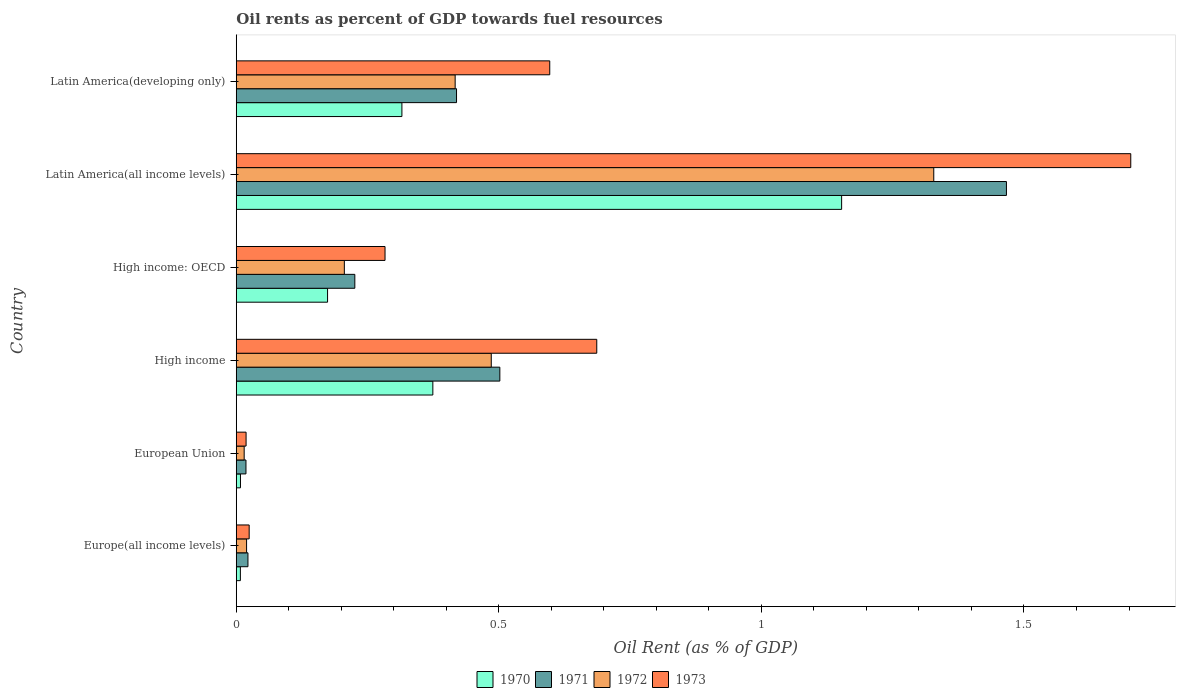How many different coloured bars are there?
Your answer should be compact. 4. Are the number of bars on each tick of the Y-axis equal?
Offer a very short reply. Yes. How many bars are there on the 6th tick from the top?
Offer a terse response. 4. What is the label of the 6th group of bars from the top?
Give a very brief answer. Europe(all income levels). In how many cases, is the number of bars for a given country not equal to the number of legend labels?
Offer a very short reply. 0. What is the oil rent in 1970 in High income: OECD?
Ensure brevity in your answer.  0.17. Across all countries, what is the maximum oil rent in 1972?
Make the answer very short. 1.33. Across all countries, what is the minimum oil rent in 1970?
Provide a succinct answer. 0.01. In which country was the oil rent in 1971 maximum?
Provide a succinct answer. Latin America(all income levels). In which country was the oil rent in 1970 minimum?
Keep it short and to the point. Europe(all income levels). What is the total oil rent in 1972 in the graph?
Your answer should be compact. 2.47. What is the difference between the oil rent in 1971 in Europe(all income levels) and that in High income?
Keep it short and to the point. -0.48. What is the difference between the oil rent in 1973 in Latin America(all income levels) and the oil rent in 1971 in European Union?
Your answer should be very brief. 1.68. What is the average oil rent in 1973 per country?
Your response must be concise. 0.55. What is the difference between the oil rent in 1970 and oil rent in 1971 in High income?
Provide a succinct answer. -0.13. What is the ratio of the oil rent in 1971 in Europe(all income levels) to that in High income?
Make the answer very short. 0.04. Is the oil rent in 1973 in High income: OECD less than that in Latin America(developing only)?
Your response must be concise. Yes. Is the difference between the oil rent in 1970 in Europe(all income levels) and High income greater than the difference between the oil rent in 1971 in Europe(all income levels) and High income?
Provide a succinct answer. Yes. What is the difference between the highest and the second highest oil rent in 1972?
Make the answer very short. 0.84. What is the difference between the highest and the lowest oil rent in 1971?
Ensure brevity in your answer.  1.45. In how many countries, is the oil rent in 1971 greater than the average oil rent in 1971 taken over all countries?
Your answer should be compact. 2. Are all the bars in the graph horizontal?
Your answer should be compact. Yes. Does the graph contain any zero values?
Offer a very short reply. No. Does the graph contain grids?
Provide a succinct answer. No. Where does the legend appear in the graph?
Ensure brevity in your answer.  Bottom center. How are the legend labels stacked?
Offer a terse response. Horizontal. What is the title of the graph?
Keep it short and to the point. Oil rents as percent of GDP towards fuel resources. What is the label or title of the X-axis?
Give a very brief answer. Oil Rent (as % of GDP). What is the Oil Rent (as % of GDP) of 1970 in Europe(all income levels)?
Provide a succinct answer. 0.01. What is the Oil Rent (as % of GDP) in 1971 in Europe(all income levels)?
Provide a short and direct response. 0.02. What is the Oil Rent (as % of GDP) in 1972 in Europe(all income levels)?
Ensure brevity in your answer.  0.02. What is the Oil Rent (as % of GDP) of 1973 in Europe(all income levels)?
Offer a very short reply. 0.02. What is the Oil Rent (as % of GDP) of 1970 in European Union?
Offer a terse response. 0.01. What is the Oil Rent (as % of GDP) of 1971 in European Union?
Your answer should be very brief. 0.02. What is the Oil Rent (as % of GDP) of 1972 in European Union?
Provide a short and direct response. 0.02. What is the Oil Rent (as % of GDP) of 1973 in European Union?
Offer a terse response. 0.02. What is the Oil Rent (as % of GDP) in 1970 in High income?
Ensure brevity in your answer.  0.37. What is the Oil Rent (as % of GDP) in 1971 in High income?
Your response must be concise. 0.5. What is the Oil Rent (as % of GDP) in 1972 in High income?
Offer a very short reply. 0.49. What is the Oil Rent (as % of GDP) of 1973 in High income?
Give a very brief answer. 0.69. What is the Oil Rent (as % of GDP) of 1970 in High income: OECD?
Ensure brevity in your answer.  0.17. What is the Oil Rent (as % of GDP) of 1971 in High income: OECD?
Give a very brief answer. 0.23. What is the Oil Rent (as % of GDP) in 1972 in High income: OECD?
Your answer should be very brief. 0.21. What is the Oil Rent (as % of GDP) of 1973 in High income: OECD?
Offer a terse response. 0.28. What is the Oil Rent (as % of GDP) of 1970 in Latin America(all income levels)?
Your answer should be compact. 1.15. What is the Oil Rent (as % of GDP) of 1971 in Latin America(all income levels)?
Offer a very short reply. 1.47. What is the Oil Rent (as % of GDP) in 1972 in Latin America(all income levels)?
Keep it short and to the point. 1.33. What is the Oil Rent (as % of GDP) of 1973 in Latin America(all income levels)?
Your response must be concise. 1.7. What is the Oil Rent (as % of GDP) of 1970 in Latin America(developing only)?
Ensure brevity in your answer.  0.32. What is the Oil Rent (as % of GDP) in 1971 in Latin America(developing only)?
Provide a short and direct response. 0.42. What is the Oil Rent (as % of GDP) in 1972 in Latin America(developing only)?
Ensure brevity in your answer.  0.42. What is the Oil Rent (as % of GDP) in 1973 in Latin America(developing only)?
Provide a short and direct response. 0.6. Across all countries, what is the maximum Oil Rent (as % of GDP) of 1970?
Make the answer very short. 1.15. Across all countries, what is the maximum Oil Rent (as % of GDP) of 1971?
Keep it short and to the point. 1.47. Across all countries, what is the maximum Oil Rent (as % of GDP) in 1972?
Provide a succinct answer. 1.33. Across all countries, what is the maximum Oil Rent (as % of GDP) in 1973?
Offer a very short reply. 1.7. Across all countries, what is the minimum Oil Rent (as % of GDP) of 1970?
Provide a short and direct response. 0.01. Across all countries, what is the minimum Oil Rent (as % of GDP) of 1971?
Provide a succinct answer. 0.02. Across all countries, what is the minimum Oil Rent (as % of GDP) of 1972?
Ensure brevity in your answer.  0.02. Across all countries, what is the minimum Oil Rent (as % of GDP) in 1973?
Ensure brevity in your answer.  0.02. What is the total Oil Rent (as % of GDP) of 1970 in the graph?
Provide a succinct answer. 2.03. What is the total Oil Rent (as % of GDP) in 1971 in the graph?
Ensure brevity in your answer.  2.65. What is the total Oil Rent (as % of GDP) in 1972 in the graph?
Your answer should be compact. 2.47. What is the total Oil Rent (as % of GDP) of 1973 in the graph?
Offer a very short reply. 3.31. What is the difference between the Oil Rent (as % of GDP) of 1970 in Europe(all income levels) and that in European Union?
Keep it short and to the point. -0. What is the difference between the Oil Rent (as % of GDP) in 1971 in Europe(all income levels) and that in European Union?
Make the answer very short. 0. What is the difference between the Oil Rent (as % of GDP) in 1972 in Europe(all income levels) and that in European Union?
Offer a terse response. 0. What is the difference between the Oil Rent (as % of GDP) in 1973 in Europe(all income levels) and that in European Union?
Give a very brief answer. 0.01. What is the difference between the Oil Rent (as % of GDP) in 1970 in Europe(all income levels) and that in High income?
Your answer should be compact. -0.37. What is the difference between the Oil Rent (as % of GDP) in 1971 in Europe(all income levels) and that in High income?
Give a very brief answer. -0.48. What is the difference between the Oil Rent (as % of GDP) in 1972 in Europe(all income levels) and that in High income?
Provide a short and direct response. -0.47. What is the difference between the Oil Rent (as % of GDP) of 1973 in Europe(all income levels) and that in High income?
Your answer should be compact. -0.66. What is the difference between the Oil Rent (as % of GDP) of 1970 in Europe(all income levels) and that in High income: OECD?
Offer a terse response. -0.17. What is the difference between the Oil Rent (as % of GDP) of 1971 in Europe(all income levels) and that in High income: OECD?
Give a very brief answer. -0.2. What is the difference between the Oil Rent (as % of GDP) in 1972 in Europe(all income levels) and that in High income: OECD?
Ensure brevity in your answer.  -0.19. What is the difference between the Oil Rent (as % of GDP) in 1973 in Europe(all income levels) and that in High income: OECD?
Provide a succinct answer. -0.26. What is the difference between the Oil Rent (as % of GDP) in 1970 in Europe(all income levels) and that in Latin America(all income levels)?
Make the answer very short. -1.14. What is the difference between the Oil Rent (as % of GDP) of 1971 in Europe(all income levels) and that in Latin America(all income levels)?
Your response must be concise. -1.44. What is the difference between the Oil Rent (as % of GDP) of 1972 in Europe(all income levels) and that in Latin America(all income levels)?
Give a very brief answer. -1.31. What is the difference between the Oil Rent (as % of GDP) of 1973 in Europe(all income levels) and that in Latin America(all income levels)?
Your answer should be very brief. -1.68. What is the difference between the Oil Rent (as % of GDP) of 1970 in Europe(all income levels) and that in Latin America(developing only)?
Your answer should be very brief. -0.31. What is the difference between the Oil Rent (as % of GDP) in 1971 in Europe(all income levels) and that in Latin America(developing only)?
Your answer should be compact. -0.4. What is the difference between the Oil Rent (as % of GDP) in 1972 in Europe(all income levels) and that in Latin America(developing only)?
Provide a succinct answer. -0.4. What is the difference between the Oil Rent (as % of GDP) of 1973 in Europe(all income levels) and that in Latin America(developing only)?
Offer a very short reply. -0.57. What is the difference between the Oil Rent (as % of GDP) in 1970 in European Union and that in High income?
Provide a succinct answer. -0.37. What is the difference between the Oil Rent (as % of GDP) in 1971 in European Union and that in High income?
Your answer should be compact. -0.48. What is the difference between the Oil Rent (as % of GDP) in 1972 in European Union and that in High income?
Offer a terse response. -0.47. What is the difference between the Oil Rent (as % of GDP) of 1973 in European Union and that in High income?
Provide a succinct answer. -0.67. What is the difference between the Oil Rent (as % of GDP) of 1970 in European Union and that in High income: OECD?
Your response must be concise. -0.17. What is the difference between the Oil Rent (as % of GDP) in 1971 in European Union and that in High income: OECD?
Keep it short and to the point. -0.21. What is the difference between the Oil Rent (as % of GDP) in 1972 in European Union and that in High income: OECD?
Offer a very short reply. -0.19. What is the difference between the Oil Rent (as % of GDP) in 1973 in European Union and that in High income: OECD?
Your answer should be compact. -0.26. What is the difference between the Oil Rent (as % of GDP) of 1970 in European Union and that in Latin America(all income levels)?
Your response must be concise. -1.14. What is the difference between the Oil Rent (as % of GDP) in 1971 in European Union and that in Latin America(all income levels)?
Give a very brief answer. -1.45. What is the difference between the Oil Rent (as % of GDP) in 1972 in European Union and that in Latin America(all income levels)?
Ensure brevity in your answer.  -1.31. What is the difference between the Oil Rent (as % of GDP) of 1973 in European Union and that in Latin America(all income levels)?
Make the answer very short. -1.68. What is the difference between the Oil Rent (as % of GDP) in 1970 in European Union and that in Latin America(developing only)?
Offer a very short reply. -0.31. What is the difference between the Oil Rent (as % of GDP) of 1971 in European Union and that in Latin America(developing only)?
Ensure brevity in your answer.  -0.4. What is the difference between the Oil Rent (as % of GDP) in 1972 in European Union and that in Latin America(developing only)?
Provide a short and direct response. -0.4. What is the difference between the Oil Rent (as % of GDP) of 1973 in European Union and that in Latin America(developing only)?
Provide a short and direct response. -0.58. What is the difference between the Oil Rent (as % of GDP) in 1970 in High income and that in High income: OECD?
Ensure brevity in your answer.  0.2. What is the difference between the Oil Rent (as % of GDP) in 1971 in High income and that in High income: OECD?
Your answer should be compact. 0.28. What is the difference between the Oil Rent (as % of GDP) of 1972 in High income and that in High income: OECD?
Offer a terse response. 0.28. What is the difference between the Oil Rent (as % of GDP) of 1973 in High income and that in High income: OECD?
Ensure brevity in your answer.  0.4. What is the difference between the Oil Rent (as % of GDP) in 1970 in High income and that in Latin America(all income levels)?
Your answer should be compact. -0.78. What is the difference between the Oil Rent (as % of GDP) of 1971 in High income and that in Latin America(all income levels)?
Your answer should be compact. -0.96. What is the difference between the Oil Rent (as % of GDP) in 1972 in High income and that in Latin America(all income levels)?
Your answer should be very brief. -0.84. What is the difference between the Oil Rent (as % of GDP) in 1973 in High income and that in Latin America(all income levels)?
Your answer should be compact. -1.02. What is the difference between the Oil Rent (as % of GDP) of 1970 in High income and that in Latin America(developing only)?
Keep it short and to the point. 0.06. What is the difference between the Oil Rent (as % of GDP) in 1971 in High income and that in Latin America(developing only)?
Your answer should be compact. 0.08. What is the difference between the Oil Rent (as % of GDP) in 1972 in High income and that in Latin America(developing only)?
Your response must be concise. 0.07. What is the difference between the Oil Rent (as % of GDP) of 1973 in High income and that in Latin America(developing only)?
Give a very brief answer. 0.09. What is the difference between the Oil Rent (as % of GDP) of 1970 in High income: OECD and that in Latin America(all income levels)?
Offer a very short reply. -0.98. What is the difference between the Oil Rent (as % of GDP) in 1971 in High income: OECD and that in Latin America(all income levels)?
Ensure brevity in your answer.  -1.24. What is the difference between the Oil Rent (as % of GDP) of 1972 in High income: OECD and that in Latin America(all income levels)?
Offer a terse response. -1.12. What is the difference between the Oil Rent (as % of GDP) in 1973 in High income: OECD and that in Latin America(all income levels)?
Keep it short and to the point. -1.42. What is the difference between the Oil Rent (as % of GDP) of 1970 in High income: OECD and that in Latin America(developing only)?
Ensure brevity in your answer.  -0.14. What is the difference between the Oil Rent (as % of GDP) in 1971 in High income: OECD and that in Latin America(developing only)?
Provide a succinct answer. -0.19. What is the difference between the Oil Rent (as % of GDP) of 1972 in High income: OECD and that in Latin America(developing only)?
Offer a terse response. -0.21. What is the difference between the Oil Rent (as % of GDP) in 1973 in High income: OECD and that in Latin America(developing only)?
Your answer should be compact. -0.31. What is the difference between the Oil Rent (as % of GDP) in 1970 in Latin America(all income levels) and that in Latin America(developing only)?
Your response must be concise. 0.84. What is the difference between the Oil Rent (as % of GDP) in 1971 in Latin America(all income levels) and that in Latin America(developing only)?
Give a very brief answer. 1.05. What is the difference between the Oil Rent (as % of GDP) of 1972 in Latin America(all income levels) and that in Latin America(developing only)?
Your answer should be compact. 0.91. What is the difference between the Oil Rent (as % of GDP) of 1973 in Latin America(all income levels) and that in Latin America(developing only)?
Your response must be concise. 1.11. What is the difference between the Oil Rent (as % of GDP) in 1970 in Europe(all income levels) and the Oil Rent (as % of GDP) in 1971 in European Union?
Offer a terse response. -0.01. What is the difference between the Oil Rent (as % of GDP) of 1970 in Europe(all income levels) and the Oil Rent (as % of GDP) of 1972 in European Union?
Your answer should be compact. -0.01. What is the difference between the Oil Rent (as % of GDP) in 1970 in Europe(all income levels) and the Oil Rent (as % of GDP) in 1973 in European Union?
Provide a succinct answer. -0.01. What is the difference between the Oil Rent (as % of GDP) of 1971 in Europe(all income levels) and the Oil Rent (as % of GDP) of 1972 in European Union?
Your answer should be compact. 0.01. What is the difference between the Oil Rent (as % of GDP) of 1971 in Europe(all income levels) and the Oil Rent (as % of GDP) of 1973 in European Union?
Ensure brevity in your answer.  0. What is the difference between the Oil Rent (as % of GDP) in 1972 in Europe(all income levels) and the Oil Rent (as % of GDP) in 1973 in European Union?
Offer a very short reply. 0. What is the difference between the Oil Rent (as % of GDP) of 1970 in Europe(all income levels) and the Oil Rent (as % of GDP) of 1971 in High income?
Your answer should be very brief. -0.49. What is the difference between the Oil Rent (as % of GDP) in 1970 in Europe(all income levels) and the Oil Rent (as % of GDP) in 1972 in High income?
Give a very brief answer. -0.48. What is the difference between the Oil Rent (as % of GDP) of 1970 in Europe(all income levels) and the Oil Rent (as % of GDP) of 1973 in High income?
Offer a very short reply. -0.68. What is the difference between the Oil Rent (as % of GDP) of 1971 in Europe(all income levels) and the Oil Rent (as % of GDP) of 1972 in High income?
Offer a very short reply. -0.46. What is the difference between the Oil Rent (as % of GDP) of 1971 in Europe(all income levels) and the Oil Rent (as % of GDP) of 1973 in High income?
Offer a very short reply. -0.66. What is the difference between the Oil Rent (as % of GDP) in 1972 in Europe(all income levels) and the Oil Rent (as % of GDP) in 1973 in High income?
Offer a terse response. -0.67. What is the difference between the Oil Rent (as % of GDP) of 1970 in Europe(all income levels) and the Oil Rent (as % of GDP) of 1971 in High income: OECD?
Your response must be concise. -0.22. What is the difference between the Oil Rent (as % of GDP) of 1970 in Europe(all income levels) and the Oil Rent (as % of GDP) of 1972 in High income: OECD?
Offer a terse response. -0.2. What is the difference between the Oil Rent (as % of GDP) of 1970 in Europe(all income levels) and the Oil Rent (as % of GDP) of 1973 in High income: OECD?
Your answer should be compact. -0.28. What is the difference between the Oil Rent (as % of GDP) of 1971 in Europe(all income levels) and the Oil Rent (as % of GDP) of 1972 in High income: OECD?
Provide a short and direct response. -0.18. What is the difference between the Oil Rent (as % of GDP) of 1971 in Europe(all income levels) and the Oil Rent (as % of GDP) of 1973 in High income: OECD?
Offer a very short reply. -0.26. What is the difference between the Oil Rent (as % of GDP) in 1972 in Europe(all income levels) and the Oil Rent (as % of GDP) in 1973 in High income: OECD?
Your answer should be very brief. -0.26. What is the difference between the Oil Rent (as % of GDP) of 1970 in Europe(all income levels) and the Oil Rent (as % of GDP) of 1971 in Latin America(all income levels)?
Offer a very short reply. -1.46. What is the difference between the Oil Rent (as % of GDP) of 1970 in Europe(all income levels) and the Oil Rent (as % of GDP) of 1972 in Latin America(all income levels)?
Provide a succinct answer. -1.32. What is the difference between the Oil Rent (as % of GDP) in 1970 in Europe(all income levels) and the Oil Rent (as % of GDP) in 1973 in Latin America(all income levels)?
Make the answer very short. -1.7. What is the difference between the Oil Rent (as % of GDP) in 1971 in Europe(all income levels) and the Oil Rent (as % of GDP) in 1972 in Latin America(all income levels)?
Provide a succinct answer. -1.31. What is the difference between the Oil Rent (as % of GDP) of 1971 in Europe(all income levels) and the Oil Rent (as % of GDP) of 1973 in Latin America(all income levels)?
Offer a very short reply. -1.68. What is the difference between the Oil Rent (as % of GDP) of 1972 in Europe(all income levels) and the Oil Rent (as % of GDP) of 1973 in Latin America(all income levels)?
Offer a terse response. -1.68. What is the difference between the Oil Rent (as % of GDP) of 1970 in Europe(all income levels) and the Oil Rent (as % of GDP) of 1971 in Latin America(developing only)?
Provide a succinct answer. -0.41. What is the difference between the Oil Rent (as % of GDP) of 1970 in Europe(all income levels) and the Oil Rent (as % of GDP) of 1972 in Latin America(developing only)?
Your answer should be compact. -0.41. What is the difference between the Oil Rent (as % of GDP) of 1970 in Europe(all income levels) and the Oil Rent (as % of GDP) of 1973 in Latin America(developing only)?
Offer a very short reply. -0.59. What is the difference between the Oil Rent (as % of GDP) in 1971 in Europe(all income levels) and the Oil Rent (as % of GDP) in 1972 in Latin America(developing only)?
Your answer should be compact. -0.39. What is the difference between the Oil Rent (as % of GDP) of 1971 in Europe(all income levels) and the Oil Rent (as % of GDP) of 1973 in Latin America(developing only)?
Your response must be concise. -0.57. What is the difference between the Oil Rent (as % of GDP) of 1972 in Europe(all income levels) and the Oil Rent (as % of GDP) of 1973 in Latin America(developing only)?
Provide a short and direct response. -0.58. What is the difference between the Oil Rent (as % of GDP) in 1970 in European Union and the Oil Rent (as % of GDP) in 1971 in High income?
Offer a very short reply. -0.49. What is the difference between the Oil Rent (as % of GDP) in 1970 in European Union and the Oil Rent (as % of GDP) in 1972 in High income?
Your response must be concise. -0.48. What is the difference between the Oil Rent (as % of GDP) in 1970 in European Union and the Oil Rent (as % of GDP) in 1973 in High income?
Ensure brevity in your answer.  -0.68. What is the difference between the Oil Rent (as % of GDP) of 1971 in European Union and the Oil Rent (as % of GDP) of 1972 in High income?
Keep it short and to the point. -0.47. What is the difference between the Oil Rent (as % of GDP) in 1971 in European Union and the Oil Rent (as % of GDP) in 1973 in High income?
Provide a short and direct response. -0.67. What is the difference between the Oil Rent (as % of GDP) in 1972 in European Union and the Oil Rent (as % of GDP) in 1973 in High income?
Your response must be concise. -0.67. What is the difference between the Oil Rent (as % of GDP) in 1970 in European Union and the Oil Rent (as % of GDP) in 1971 in High income: OECD?
Your response must be concise. -0.22. What is the difference between the Oil Rent (as % of GDP) of 1970 in European Union and the Oil Rent (as % of GDP) of 1972 in High income: OECD?
Offer a terse response. -0.2. What is the difference between the Oil Rent (as % of GDP) in 1970 in European Union and the Oil Rent (as % of GDP) in 1973 in High income: OECD?
Keep it short and to the point. -0.28. What is the difference between the Oil Rent (as % of GDP) in 1971 in European Union and the Oil Rent (as % of GDP) in 1972 in High income: OECD?
Your answer should be compact. -0.19. What is the difference between the Oil Rent (as % of GDP) in 1971 in European Union and the Oil Rent (as % of GDP) in 1973 in High income: OECD?
Your answer should be very brief. -0.26. What is the difference between the Oil Rent (as % of GDP) of 1972 in European Union and the Oil Rent (as % of GDP) of 1973 in High income: OECD?
Provide a succinct answer. -0.27. What is the difference between the Oil Rent (as % of GDP) in 1970 in European Union and the Oil Rent (as % of GDP) in 1971 in Latin America(all income levels)?
Offer a terse response. -1.46. What is the difference between the Oil Rent (as % of GDP) of 1970 in European Union and the Oil Rent (as % of GDP) of 1972 in Latin America(all income levels)?
Offer a very short reply. -1.32. What is the difference between the Oil Rent (as % of GDP) of 1970 in European Union and the Oil Rent (as % of GDP) of 1973 in Latin America(all income levels)?
Make the answer very short. -1.7. What is the difference between the Oil Rent (as % of GDP) of 1971 in European Union and the Oil Rent (as % of GDP) of 1972 in Latin America(all income levels)?
Provide a short and direct response. -1.31. What is the difference between the Oil Rent (as % of GDP) in 1971 in European Union and the Oil Rent (as % of GDP) in 1973 in Latin America(all income levels)?
Your response must be concise. -1.68. What is the difference between the Oil Rent (as % of GDP) in 1972 in European Union and the Oil Rent (as % of GDP) in 1973 in Latin America(all income levels)?
Make the answer very short. -1.69. What is the difference between the Oil Rent (as % of GDP) in 1970 in European Union and the Oil Rent (as % of GDP) in 1971 in Latin America(developing only)?
Your answer should be compact. -0.41. What is the difference between the Oil Rent (as % of GDP) of 1970 in European Union and the Oil Rent (as % of GDP) of 1972 in Latin America(developing only)?
Ensure brevity in your answer.  -0.41. What is the difference between the Oil Rent (as % of GDP) in 1970 in European Union and the Oil Rent (as % of GDP) in 1973 in Latin America(developing only)?
Your answer should be very brief. -0.59. What is the difference between the Oil Rent (as % of GDP) in 1971 in European Union and the Oil Rent (as % of GDP) in 1972 in Latin America(developing only)?
Your answer should be very brief. -0.4. What is the difference between the Oil Rent (as % of GDP) of 1971 in European Union and the Oil Rent (as % of GDP) of 1973 in Latin America(developing only)?
Your answer should be very brief. -0.58. What is the difference between the Oil Rent (as % of GDP) of 1972 in European Union and the Oil Rent (as % of GDP) of 1973 in Latin America(developing only)?
Make the answer very short. -0.58. What is the difference between the Oil Rent (as % of GDP) of 1970 in High income and the Oil Rent (as % of GDP) of 1971 in High income: OECD?
Give a very brief answer. 0.15. What is the difference between the Oil Rent (as % of GDP) in 1970 in High income and the Oil Rent (as % of GDP) in 1972 in High income: OECD?
Give a very brief answer. 0.17. What is the difference between the Oil Rent (as % of GDP) of 1970 in High income and the Oil Rent (as % of GDP) of 1973 in High income: OECD?
Provide a succinct answer. 0.09. What is the difference between the Oil Rent (as % of GDP) of 1971 in High income and the Oil Rent (as % of GDP) of 1972 in High income: OECD?
Provide a short and direct response. 0.3. What is the difference between the Oil Rent (as % of GDP) of 1971 in High income and the Oil Rent (as % of GDP) of 1973 in High income: OECD?
Your response must be concise. 0.22. What is the difference between the Oil Rent (as % of GDP) of 1972 in High income and the Oil Rent (as % of GDP) of 1973 in High income: OECD?
Ensure brevity in your answer.  0.2. What is the difference between the Oil Rent (as % of GDP) of 1970 in High income and the Oil Rent (as % of GDP) of 1971 in Latin America(all income levels)?
Your answer should be very brief. -1.09. What is the difference between the Oil Rent (as % of GDP) in 1970 in High income and the Oil Rent (as % of GDP) in 1972 in Latin America(all income levels)?
Provide a succinct answer. -0.95. What is the difference between the Oil Rent (as % of GDP) of 1970 in High income and the Oil Rent (as % of GDP) of 1973 in Latin America(all income levels)?
Give a very brief answer. -1.33. What is the difference between the Oil Rent (as % of GDP) in 1971 in High income and the Oil Rent (as % of GDP) in 1972 in Latin America(all income levels)?
Offer a very short reply. -0.83. What is the difference between the Oil Rent (as % of GDP) of 1971 in High income and the Oil Rent (as % of GDP) of 1973 in Latin America(all income levels)?
Offer a very short reply. -1.2. What is the difference between the Oil Rent (as % of GDP) of 1972 in High income and the Oil Rent (as % of GDP) of 1973 in Latin America(all income levels)?
Ensure brevity in your answer.  -1.22. What is the difference between the Oil Rent (as % of GDP) of 1970 in High income and the Oil Rent (as % of GDP) of 1971 in Latin America(developing only)?
Provide a succinct answer. -0.05. What is the difference between the Oil Rent (as % of GDP) of 1970 in High income and the Oil Rent (as % of GDP) of 1972 in Latin America(developing only)?
Provide a succinct answer. -0.04. What is the difference between the Oil Rent (as % of GDP) in 1970 in High income and the Oil Rent (as % of GDP) in 1973 in Latin America(developing only)?
Provide a succinct answer. -0.22. What is the difference between the Oil Rent (as % of GDP) in 1971 in High income and the Oil Rent (as % of GDP) in 1972 in Latin America(developing only)?
Make the answer very short. 0.09. What is the difference between the Oil Rent (as % of GDP) in 1971 in High income and the Oil Rent (as % of GDP) in 1973 in Latin America(developing only)?
Give a very brief answer. -0.1. What is the difference between the Oil Rent (as % of GDP) of 1972 in High income and the Oil Rent (as % of GDP) of 1973 in Latin America(developing only)?
Provide a succinct answer. -0.11. What is the difference between the Oil Rent (as % of GDP) of 1970 in High income: OECD and the Oil Rent (as % of GDP) of 1971 in Latin America(all income levels)?
Keep it short and to the point. -1.29. What is the difference between the Oil Rent (as % of GDP) in 1970 in High income: OECD and the Oil Rent (as % of GDP) in 1972 in Latin America(all income levels)?
Offer a very short reply. -1.15. What is the difference between the Oil Rent (as % of GDP) of 1970 in High income: OECD and the Oil Rent (as % of GDP) of 1973 in Latin America(all income levels)?
Ensure brevity in your answer.  -1.53. What is the difference between the Oil Rent (as % of GDP) in 1971 in High income: OECD and the Oil Rent (as % of GDP) in 1972 in Latin America(all income levels)?
Provide a short and direct response. -1.1. What is the difference between the Oil Rent (as % of GDP) of 1971 in High income: OECD and the Oil Rent (as % of GDP) of 1973 in Latin America(all income levels)?
Offer a very short reply. -1.48. What is the difference between the Oil Rent (as % of GDP) of 1972 in High income: OECD and the Oil Rent (as % of GDP) of 1973 in Latin America(all income levels)?
Offer a terse response. -1.5. What is the difference between the Oil Rent (as % of GDP) in 1970 in High income: OECD and the Oil Rent (as % of GDP) in 1971 in Latin America(developing only)?
Your answer should be very brief. -0.25. What is the difference between the Oil Rent (as % of GDP) in 1970 in High income: OECD and the Oil Rent (as % of GDP) in 1972 in Latin America(developing only)?
Offer a very short reply. -0.24. What is the difference between the Oil Rent (as % of GDP) of 1970 in High income: OECD and the Oil Rent (as % of GDP) of 1973 in Latin America(developing only)?
Give a very brief answer. -0.42. What is the difference between the Oil Rent (as % of GDP) of 1971 in High income: OECD and the Oil Rent (as % of GDP) of 1972 in Latin America(developing only)?
Your answer should be very brief. -0.19. What is the difference between the Oil Rent (as % of GDP) in 1971 in High income: OECD and the Oil Rent (as % of GDP) in 1973 in Latin America(developing only)?
Keep it short and to the point. -0.37. What is the difference between the Oil Rent (as % of GDP) of 1972 in High income: OECD and the Oil Rent (as % of GDP) of 1973 in Latin America(developing only)?
Make the answer very short. -0.39. What is the difference between the Oil Rent (as % of GDP) in 1970 in Latin America(all income levels) and the Oil Rent (as % of GDP) in 1971 in Latin America(developing only)?
Your response must be concise. 0.73. What is the difference between the Oil Rent (as % of GDP) in 1970 in Latin America(all income levels) and the Oil Rent (as % of GDP) in 1972 in Latin America(developing only)?
Offer a very short reply. 0.74. What is the difference between the Oil Rent (as % of GDP) of 1970 in Latin America(all income levels) and the Oil Rent (as % of GDP) of 1973 in Latin America(developing only)?
Provide a succinct answer. 0.56. What is the difference between the Oil Rent (as % of GDP) in 1971 in Latin America(all income levels) and the Oil Rent (as % of GDP) in 1972 in Latin America(developing only)?
Provide a succinct answer. 1.05. What is the difference between the Oil Rent (as % of GDP) of 1971 in Latin America(all income levels) and the Oil Rent (as % of GDP) of 1973 in Latin America(developing only)?
Give a very brief answer. 0.87. What is the difference between the Oil Rent (as % of GDP) in 1972 in Latin America(all income levels) and the Oil Rent (as % of GDP) in 1973 in Latin America(developing only)?
Offer a terse response. 0.73. What is the average Oil Rent (as % of GDP) in 1970 per country?
Provide a succinct answer. 0.34. What is the average Oil Rent (as % of GDP) of 1971 per country?
Offer a very short reply. 0.44. What is the average Oil Rent (as % of GDP) in 1972 per country?
Ensure brevity in your answer.  0.41. What is the average Oil Rent (as % of GDP) in 1973 per country?
Ensure brevity in your answer.  0.55. What is the difference between the Oil Rent (as % of GDP) in 1970 and Oil Rent (as % of GDP) in 1971 in Europe(all income levels)?
Make the answer very short. -0.01. What is the difference between the Oil Rent (as % of GDP) of 1970 and Oil Rent (as % of GDP) of 1972 in Europe(all income levels)?
Your answer should be very brief. -0.01. What is the difference between the Oil Rent (as % of GDP) of 1970 and Oil Rent (as % of GDP) of 1973 in Europe(all income levels)?
Your answer should be compact. -0.02. What is the difference between the Oil Rent (as % of GDP) of 1971 and Oil Rent (as % of GDP) of 1972 in Europe(all income levels)?
Ensure brevity in your answer.  0. What is the difference between the Oil Rent (as % of GDP) in 1971 and Oil Rent (as % of GDP) in 1973 in Europe(all income levels)?
Your response must be concise. -0. What is the difference between the Oil Rent (as % of GDP) in 1972 and Oil Rent (as % of GDP) in 1973 in Europe(all income levels)?
Your answer should be very brief. -0.01. What is the difference between the Oil Rent (as % of GDP) of 1970 and Oil Rent (as % of GDP) of 1971 in European Union?
Give a very brief answer. -0.01. What is the difference between the Oil Rent (as % of GDP) of 1970 and Oil Rent (as % of GDP) of 1972 in European Union?
Give a very brief answer. -0.01. What is the difference between the Oil Rent (as % of GDP) in 1970 and Oil Rent (as % of GDP) in 1973 in European Union?
Provide a short and direct response. -0.01. What is the difference between the Oil Rent (as % of GDP) in 1971 and Oil Rent (as % of GDP) in 1972 in European Union?
Give a very brief answer. 0. What is the difference between the Oil Rent (as % of GDP) in 1971 and Oil Rent (as % of GDP) in 1973 in European Union?
Ensure brevity in your answer.  -0. What is the difference between the Oil Rent (as % of GDP) of 1972 and Oil Rent (as % of GDP) of 1973 in European Union?
Make the answer very short. -0. What is the difference between the Oil Rent (as % of GDP) in 1970 and Oil Rent (as % of GDP) in 1971 in High income?
Provide a succinct answer. -0.13. What is the difference between the Oil Rent (as % of GDP) of 1970 and Oil Rent (as % of GDP) of 1972 in High income?
Offer a terse response. -0.11. What is the difference between the Oil Rent (as % of GDP) in 1970 and Oil Rent (as % of GDP) in 1973 in High income?
Your response must be concise. -0.31. What is the difference between the Oil Rent (as % of GDP) of 1971 and Oil Rent (as % of GDP) of 1972 in High income?
Make the answer very short. 0.02. What is the difference between the Oil Rent (as % of GDP) in 1971 and Oil Rent (as % of GDP) in 1973 in High income?
Ensure brevity in your answer.  -0.18. What is the difference between the Oil Rent (as % of GDP) of 1972 and Oil Rent (as % of GDP) of 1973 in High income?
Your response must be concise. -0.2. What is the difference between the Oil Rent (as % of GDP) of 1970 and Oil Rent (as % of GDP) of 1971 in High income: OECD?
Keep it short and to the point. -0.05. What is the difference between the Oil Rent (as % of GDP) in 1970 and Oil Rent (as % of GDP) in 1972 in High income: OECD?
Provide a succinct answer. -0.03. What is the difference between the Oil Rent (as % of GDP) in 1970 and Oil Rent (as % of GDP) in 1973 in High income: OECD?
Your answer should be very brief. -0.11. What is the difference between the Oil Rent (as % of GDP) in 1971 and Oil Rent (as % of GDP) in 1972 in High income: OECD?
Your response must be concise. 0.02. What is the difference between the Oil Rent (as % of GDP) in 1971 and Oil Rent (as % of GDP) in 1973 in High income: OECD?
Keep it short and to the point. -0.06. What is the difference between the Oil Rent (as % of GDP) of 1972 and Oil Rent (as % of GDP) of 1973 in High income: OECD?
Provide a succinct answer. -0.08. What is the difference between the Oil Rent (as % of GDP) of 1970 and Oil Rent (as % of GDP) of 1971 in Latin America(all income levels)?
Provide a short and direct response. -0.31. What is the difference between the Oil Rent (as % of GDP) in 1970 and Oil Rent (as % of GDP) in 1972 in Latin America(all income levels)?
Keep it short and to the point. -0.18. What is the difference between the Oil Rent (as % of GDP) in 1970 and Oil Rent (as % of GDP) in 1973 in Latin America(all income levels)?
Provide a short and direct response. -0.55. What is the difference between the Oil Rent (as % of GDP) in 1971 and Oil Rent (as % of GDP) in 1972 in Latin America(all income levels)?
Keep it short and to the point. 0.14. What is the difference between the Oil Rent (as % of GDP) in 1971 and Oil Rent (as % of GDP) in 1973 in Latin America(all income levels)?
Your answer should be very brief. -0.24. What is the difference between the Oil Rent (as % of GDP) in 1972 and Oil Rent (as % of GDP) in 1973 in Latin America(all income levels)?
Offer a terse response. -0.38. What is the difference between the Oil Rent (as % of GDP) in 1970 and Oil Rent (as % of GDP) in 1971 in Latin America(developing only)?
Your answer should be compact. -0.1. What is the difference between the Oil Rent (as % of GDP) of 1970 and Oil Rent (as % of GDP) of 1972 in Latin America(developing only)?
Your answer should be very brief. -0.1. What is the difference between the Oil Rent (as % of GDP) of 1970 and Oil Rent (as % of GDP) of 1973 in Latin America(developing only)?
Keep it short and to the point. -0.28. What is the difference between the Oil Rent (as % of GDP) in 1971 and Oil Rent (as % of GDP) in 1972 in Latin America(developing only)?
Your response must be concise. 0. What is the difference between the Oil Rent (as % of GDP) in 1971 and Oil Rent (as % of GDP) in 1973 in Latin America(developing only)?
Your answer should be very brief. -0.18. What is the difference between the Oil Rent (as % of GDP) of 1972 and Oil Rent (as % of GDP) of 1973 in Latin America(developing only)?
Offer a terse response. -0.18. What is the ratio of the Oil Rent (as % of GDP) of 1970 in Europe(all income levels) to that in European Union?
Give a very brief answer. 0.98. What is the ratio of the Oil Rent (as % of GDP) of 1971 in Europe(all income levels) to that in European Union?
Your answer should be compact. 1.2. What is the ratio of the Oil Rent (as % of GDP) of 1972 in Europe(all income levels) to that in European Union?
Your answer should be compact. 1.3. What is the ratio of the Oil Rent (as % of GDP) in 1973 in Europe(all income levels) to that in European Union?
Provide a succinct answer. 1.31. What is the ratio of the Oil Rent (as % of GDP) in 1970 in Europe(all income levels) to that in High income?
Provide a succinct answer. 0.02. What is the ratio of the Oil Rent (as % of GDP) in 1971 in Europe(all income levels) to that in High income?
Provide a short and direct response. 0.04. What is the ratio of the Oil Rent (as % of GDP) of 1972 in Europe(all income levels) to that in High income?
Your answer should be compact. 0.04. What is the ratio of the Oil Rent (as % of GDP) of 1973 in Europe(all income levels) to that in High income?
Keep it short and to the point. 0.04. What is the ratio of the Oil Rent (as % of GDP) in 1970 in Europe(all income levels) to that in High income: OECD?
Your answer should be compact. 0.05. What is the ratio of the Oil Rent (as % of GDP) in 1971 in Europe(all income levels) to that in High income: OECD?
Give a very brief answer. 0.1. What is the ratio of the Oil Rent (as % of GDP) of 1972 in Europe(all income levels) to that in High income: OECD?
Make the answer very short. 0.1. What is the ratio of the Oil Rent (as % of GDP) in 1973 in Europe(all income levels) to that in High income: OECD?
Provide a short and direct response. 0.09. What is the ratio of the Oil Rent (as % of GDP) in 1970 in Europe(all income levels) to that in Latin America(all income levels)?
Keep it short and to the point. 0.01. What is the ratio of the Oil Rent (as % of GDP) of 1971 in Europe(all income levels) to that in Latin America(all income levels)?
Offer a very short reply. 0.02. What is the ratio of the Oil Rent (as % of GDP) in 1972 in Europe(all income levels) to that in Latin America(all income levels)?
Provide a succinct answer. 0.01. What is the ratio of the Oil Rent (as % of GDP) in 1973 in Europe(all income levels) to that in Latin America(all income levels)?
Offer a terse response. 0.01. What is the ratio of the Oil Rent (as % of GDP) in 1970 in Europe(all income levels) to that in Latin America(developing only)?
Your answer should be compact. 0.02. What is the ratio of the Oil Rent (as % of GDP) of 1971 in Europe(all income levels) to that in Latin America(developing only)?
Your response must be concise. 0.05. What is the ratio of the Oil Rent (as % of GDP) in 1972 in Europe(all income levels) to that in Latin America(developing only)?
Offer a very short reply. 0.05. What is the ratio of the Oil Rent (as % of GDP) of 1973 in Europe(all income levels) to that in Latin America(developing only)?
Provide a short and direct response. 0.04. What is the ratio of the Oil Rent (as % of GDP) in 1970 in European Union to that in High income?
Your answer should be compact. 0.02. What is the ratio of the Oil Rent (as % of GDP) of 1971 in European Union to that in High income?
Make the answer very short. 0.04. What is the ratio of the Oil Rent (as % of GDP) of 1972 in European Union to that in High income?
Provide a short and direct response. 0.03. What is the ratio of the Oil Rent (as % of GDP) in 1973 in European Union to that in High income?
Offer a terse response. 0.03. What is the ratio of the Oil Rent (as % of GDP) of 1970 in European Union to that in High income: OECD?
Offer a very short reply. 0.05. What is the ratio of the Oil Rent (as % of GDP) in 1971 in European Union to that in High income: OECD?
Make the answer very short. 0.08. What is the ratio of the Oil Rent (as % of GDP) of 1972 in European Union to that in High income: OECD?
Keep it short and to the point. 0.07. What is the ratio of the Oil Rent (as % of GDP) of 1973 in European Union to that in High income: OECD?
Provide a succinct answer. 0.07. What is the ratio of the Oil Rent (as % of GDP) in 1970 in European Union to that in Latin America(all income levels)?
Your answer should be compact. 0.01. What is the ratio of the Oil Rent (as % of GDP) of 1971 in European Union to that in Latin America(all income levels)?
Give a very brief answer. 0.01. What is the ratio of the Oil Rent (as % of GDP) in 1972 in European Union to that in Latin America(all income levels)?
Provide a succinct answer. 0.01. What is the ratio of the Oil Rent (as % of GDP) in 1973 in European Union to that in Latin America(all income levels)?
Offer a very short reply. 0.01. What is the ratio of the Oil Rent (as % of GDP) in 1970 in European Union to that in Latin America(developing only)?
Provide a short and direct response. 0.03. What is the ratio of the Oil Rent (as % of GDP) in 1971 in European Union to that in Latin America(developing only)?
Provide a succinct answer. 0.04. What is the ratio of the Oil Rent (as % of GDP) of 1972 in European Union to that in Latin America(developing only)?
Make the answer very short. 0.04. What is the ratio of the Oil Rent (as % of GDP) of 1973 in European Union to that in Latin America(developing only)?
Offer a terse response. 0.03. What is the ratio of the Oil Rent (as % of GDP) in 1970 in High income to that in High income: OECD?
Provide a succinct answer. 2.15. What is the ratio of the Oil Rent (as % of GDP) of 1971 in High income to that in High income: OECD?
Your answer should be compact. 2.22. What is the ratio of the Oil Rent (as % of GDP) of 1972 in High income to that in High income: OECD?
Provide a succinct answer. 2.36. What is the ratio of the Oil Rent (as % of GDP) of 1973 in High income to that in High income: OECD?
Your answer should be compact. 2.42. What is the ratio of the Oil Rent (as % of GDP) in 1970 in High income to that in Latin America(all income levels)?
Your answer should be very brief. 0.32. What is the ratio of the Oil Rent (as % of GDP) of 1971 in High income to that in Latin America(all income levels)?
Provide a short and direct response. 0.34. What is the ratio of the Oil Rent (as % of GDP) of 1972 in High income to that in Latin America(all income levels)?
Provide a short and direct response. 0.37. What is the ratio of the Oil Rent (as % of GDP) in 1973 in High income to that in Latin America(all income levels)?
Make the answer very short. 0.4. What is the ratio of the Oil Rent (as % of GDP) in 1970 in High income to that in Latin America(developing only)?
Ensure brevity in your answer.  1.19. What is the ratio of the Oil Rent (as % of GDP) in 1971 in High income to that in Latin America(developing only)?
Your answer should be compact. 1.2. What is the ratio of the Oil Rent (as % of GDP) in 1972 in High income to that in Latin America(developing only)?
Your answer should be compact. 1.17. What is the ratio of the Oil Rent (as % of GDP) in 1973 in High income to that in Latin America(developing only)?
Ensure brevity in your answer.  1.15. What is the ratio of the Oil Rent (as % of GDP) in 1970 in High income: OECD to that in Latin America(all income levels)?
Make the answer very short. 0.15. What is the ratio of the Oil Rent (as % of GDP) of 1971 in High income: OECD to that in Latin America(all income levels)?
Ensure brevity in your answer.  0.15. What is the ratio of the Oil Rent (as % of GDP) in 1972 in High income: OECD to that in Latin America(all income levels)?
Give a very brief answer. 0.15. What is the ratio of the Oil Rent (as % of GDP) in 1973 in High income: OECD to that in Latin America(all income levels)?
Ensure brevity in your answer.  0.17. What is the ratio of the Oil Rent (as % of GDP) in 1970 in High income: OECD to that in Latin America(developing only)?
Provide a short and direct response. 0.55. What is the ratio of the Oil Rent (as % of GDP) in 1971 in High income: OECD to that in Latin America(developing only)?
Give a very brief answer. 0.54. What is the ratio of the Oil Rent (as % of GDP) in 1972 in High income: OECD to that in Latin America(developing only)?
Ensure brevity in your answer.  0.49. What is the ratio of the Oil Rent (as % of GDP) of 1973 in High income: OECD to that in Latin America(developing only)?
Your answer should be very brief. 0.47. What is the ratio of the Oil Rent (as % of GDP) of 1970 in Latin America(all income levels) to that in Latin America(developing only)?
Give a very brief answer. 3.65. What is the ratio of the Oil Rent (as % of GDP) of 1971 in Latin America(all income levels) to that in Latin America(developing only)?
Provide a short and direct response. 3.5. What is the ratio of the Oil Rent (as % of GDP) of 1972 in Latin America(all income levels) to that in Latin America(developing only)?
Keep it short and to the point. 3.19. What is the ratio of the Oil Rent (as % of GDP) in 1973 in Latin America(all income levels) to that in Latin America(developing only)?
Your answer should be compact. 2.85. What is the difference between the highest and the second highest Oil Rent (as % of GDP) of 1970?
Provide a short and direct response. 0.78. What is the difference between the highest and the second highest Oil Rent (as % of GDP) in 1971?
Provide a short and direct response. 0.96. What is the difference between the highest and the second highest Oil Rent (as % of GDP) in 1972?
Give a very brief answer. 0.84. What is the difference between the highest and the second highest Oil Rent (as % of GDP) of 1973?
Offer a very short reply. 1.02. What is the difference between the highest and the lowest Oil Rent (as % of GDP) of 1970?
Give a very brief answer. 1.14. What is the difference between the highest and the lowest Oil Rent (as % of GDP) of 1971?
Offer a terse response. 1.45. What is the difference between the highest and the lowest Oil Rent (as % of GDP) of 1972?
Provide a short and direct response. 1.31. What is the difference between the highest and the lowest Oil Rent (as % of GDP) of 1973?
Your answer should be compact. 1.68. 